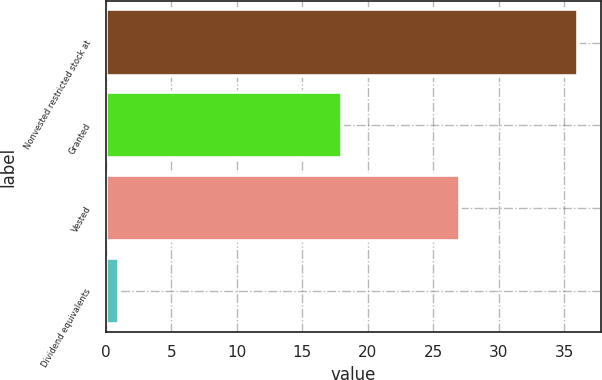Convert chart. <chart><loc_0><loc_0><loc_500><loc_500><bar_chart><fcel>Nonvested restricted stock at<fcel>Granted<fcel>Vested<fcel>Dividend equivalents<nl><fcel>36<fcel>18<fcel>27<fcel>1<nl></chart> 